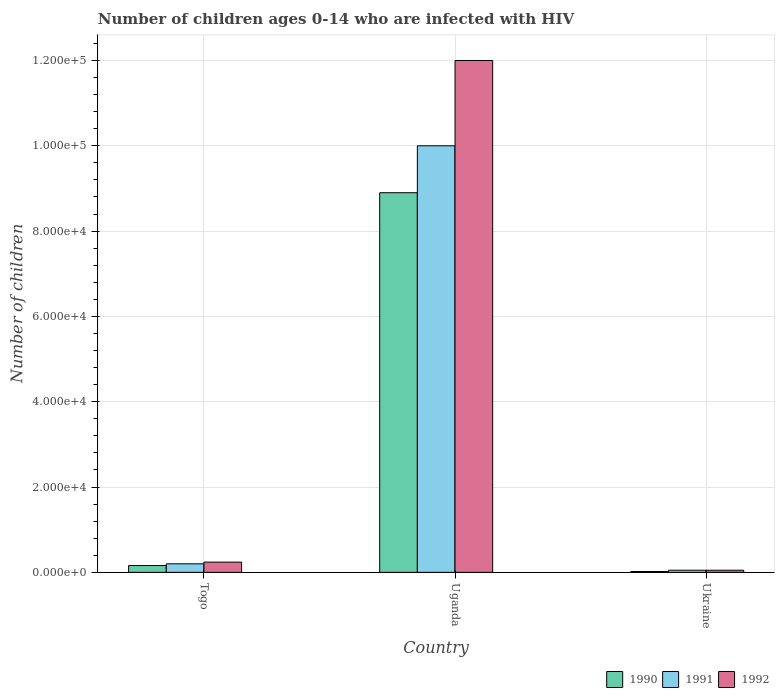How many different coloured bars are there?
Offer a very short reply. 3. How many groups of bars are there?
Provide a succinct answer. 3. Are the number of bars on each tick of the X-axis equal?
Your answer should be very brief. Yes. How many bars are there on the 2nd tick from the right?
Your response must be concise. 3. What is the label of the 3rd group of bars from the left?
Provide a short and direct response. Ukraine. In how many cases, is the number of bars for a given country not equal to the number of legend labels?
Your answer should be very brief. 0. What is the number of HIV infected children in 1991 in Togo?
Provide a succinct answer. 2000. Across all countries, what is the maximum number of HIV infected children in 1992?
Ensure brevity in your answer.  1.20e+05. Across all countries, what is the minimum number of HIV infected children in 1990?
Ensure brevity in your answer.  200. In which country was the number of HIV infected children in 1991 maximum?
Give a very brief answer. Uganda. In which country was the number of HIV infected children in 1990 minimum?
Offer a very short reply. Ukraine. What is the total number of HIV infected children in 1992 in the graph?
Your answer should be very brief. 1.23e+05. What is the difference between the number of HIV infected children in 1991 in Togo and that in Ukraine?
Offer a terse response. 1500. What is the difference between the number of HIV infected children in 1991 in Ukraine and the number of HIV infected children in 1990 in Togo?
Your answer should be compact. -1100. What is the average number of HIV infected children in 1990 per country?
Your answer should be compact. 3.03e+04. What is the difference between the number of HIV infected children of/in 1990 and number of HIV infected children of/in 1992 in Togo?
Give a very brief answer. -800. In how many countries, is the number of HIV infected children in 1991 greater than 116000?
Provide a succinct answer. 0. What is the difference between the highest and the second highest number of HIV infected children in 1992?
Ensure brevity in your answer.  1.18e+05. What is the difference between the highest and the lowest number of HIV infected children in 1991?
Make the answer very short. 9.95e+04. In how many countries, is the number of HIV infected children in 1992 greater than the average number of HIV infected children in 1992 taken over all countries?
Provide a short and direct response. 1. What does the 1st bar from the right in Uganda represents?
Provide a succinct answer. 1992. Is it the case that in every country, the sum of the number of HIV infected children in 1990 and number of HIV infected children in 1992 is greater than the number of HIV infected children in 1991?
Your answer should be very brief. Yes. How many bars are there?
Your answer should be compact. 9. Are all the bars in the graph horizontal?
Make the answer very short. No. How many countries are there in the graph?
Ensure brevity in your answer.  3. What is the difference between two consecutive major ticks on the Y-axis?
Give a very brief answer. 2.00e+04. Are the values on the major ticks of Y-axis written in scientific E-notation?
Make the answer very short. Yes. Where does the legend appear in the graph?
Your answer should be very brief. Bottom right. How many legend labels are there?
Your response must be concise. 3. How are the legend labels stacked?
Ensure brevity in your answer.  Horizontal. What is the title of the graph?
Provide a succinct answer. Number of children ages 0-14 who are infected with HIV. Does "1978" appear as one of the legend labels in the graph?
Your answer should be compact. No. What is the label or title of the Y-axis?
Give a very brief answer. Number of children. What is the Number of children in 1990 in Togo?
Keep it short and to the point. 1600. What is the Number of children of 1992 in Togo?
Make the answer very short. 2400. What is the Number of children in 1990 in Uganda?
Give a very brief answer. 8.90e+04. What is the Number of children in 1991 in Uganda?
Offer a terse response. 1.00e+05. What is the Number of children in 1992 in Uganda?
Make the answer very short. 1.20e+05. What is the Number of children in 1991 in Ukraine?
Ensure brevity in your answer.  500. Across all countries, what is the maximum Number of children of 1990?
Provide a short and direct response. 8.90e+04. Across all countries, what is the minimum Number of children of 1990?
Give a very brief answer. 200. Across all countries, what is the minimum Number of children in 1991?
Make the answer very short. 500. What is the total Number of children in 1990 in the graph?
Keep it short and to the point. 9.08e+04. What is the total Number of children of 1991 in the graph?
Your answer should be compact. 1.02e+05. What is the total Number of children of 1992 in the graph?
Your answer should be compact. 1.23e+05. What is the difference between the Number of children in 1990 in Togo and that in Uganda?
Give a very brief answer. -8.74e+04. What is the difference between the Number of children in 1991 in Togo and that in Uganda?
Offer a very short reply. -9.80e+04. What is the difference between the Number of children in 1992 in Togo and that in Uganda?
Your answer should be compact. -1.18e+05. What is the difference between the Number of children in 1990 in Togo and that in Ukraine?
Offer a very short reply. 1400. What is the difference between the Number of children of 1991 in Togo and that in Ukraine?
Give a very brief answer. 1500. What is the difference between the Number of children in 1992 in Togo and that in Ukraine?
Keep it short and to the point. 1900. What is the difference between the Number of children of 1990 in Uganda and that in Ukraine?
Your answer should be very brief. 8.88e+04. What is the difference between the Number of children of 1991 in Uganda and that in Ukraine?
Provide a short and direct response. 9.95e+04. What is the difference between the Number of children of 1992 in Uganda and that in Ukraine?
Your answer should be compact. 1.20e+05. What is the difference between the Number of children in 1990 in Togo and the Number of children in 1991 in Uganda?
Keep it short and to the point. -9.84e+04. What is the difference between the Number of children of 1990 in Togo and the Number of children of 1992 in Uganda?
Offer a terse response. -1.18e+05. What is the difference between the Number of children of 1991 in Togo and the Number of children of 1992 in Uganda?
Provide a short and direct response. -1.18e+05. What is the difference between the Number of children in 1990 in Togo and the Number of children in 1991 in Ukraine?
Your response must be concise. 1100. What is the difference between the Number of children of 1990 in Togo and the Number of children of 1992 in Ukraine?
Your answer should be compact. 1100. What is the difference between the Number of children in 1991 in Togo and the Number of children in 1992 in Ukraine?
Ensure brevity in your answer.  1500. What is the difference between the Number of children in 1990 in Uganda and the Number of children in 1991 in Ukraine?
Your answer should be very brief. 8.85e+04. What is the difference between the Number of children of 1990 in Uganda and the Number of children of 1992 in Ukraine?
Your answer should be compact. 8.85e+04. What is the difference between the Number of children in 1991 in Uganda and the Number of children in 1992 in Ukraine?
Give a very brief answer. 9.95e+04. What is the average Number of children in 1990 per country?
Provide a succinct answer. 3.03e+04. What is the average Number of children of 1991 per country?
Your answer should be compact. 3.42e+04. What is the average Number of children of 1992 per country?
Provide a succinct answer. 4.10e+04. What is the difference between the Number of children of 1990 and Number of children of 1991 in Togo?
Offer a very short reply. -400. What is the difference between the Number of children in 1990 and Number of children in 1992 in Togo?
Your response must be concise. -800. What is the difference between the Number of children in 1991 and Number of children in 1992 in Togo?
Your answer should be compact. -400. What is the difference between the Number of children in 1990 and Number of children in 1991 in Uganda?
Your answer should be very brief. -1.10e+04. What is the difference between the Number of children in 1990 and Number of children in 1992 in Uganda?
Provide a short and direct response. -3.10e+04. What is the difference between the Number of children of 1990 and Number of children of 1991 in Ukraine?
Give a very brief answer. -300. What is the difference between the Number of children in 1990 and Number of children in 1992 in Ukraine?
Make the answer very short. -300. What is the ratio of the Number of children in 1990 in Togo to that in Uganda?
Your answer should be compact. 0.02. What is the ratio of the Number of children of 1991 in Togo to that in Ukraine?
Make the answer very short. 4. What is the ratio of the Number of children of 1992 in Togo to that in Ukraine?
Offer a very short reply. 4.8. What is the ratio of the Number of children in 1990 in Uganda to that in Ukraine?
Your response must be concise. 445. What is the ratio of the Number of children in 1992 in Uganda to that in Ukraine?
Make the answer very short. 240. What is the difference between the highest and the second highest Number of children of 1990?
Your answer should be compact. 8.74e+04. What is the difference between the highest and the second highest Number of children in 1991?
Give a very brief answer. 9.80e+04. What is the difference between the highest and the second highest Number of children of 1992?
Your answer should be compact. 1.18e+05. What is the difference between the highest and the lowest Number of children in 1990?
Your answer should be compact. 8.88e+04. What is the difference between the highest and the lowest Number of children in 1991?
Make the answer very short. 9.95e+04. What is the difference between the highest and the lowest Number of children in 1992?
Give a very brief answer. 1.20e+05. 